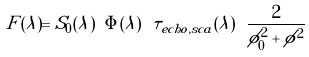Convert formula to latex. <formula><loc_0><loc_0><loc_500><loc_500>F ( \lambda ) = S _ { 0 } ( \lambda ) \ \Phi ( \lambda ) \ \tau _ { e c h o , s c a } ( \lambda ) \ \frac { 2 } { \phi ^ { 2 } _ { 0 } + \phi ^ { 2 } }</formula> 